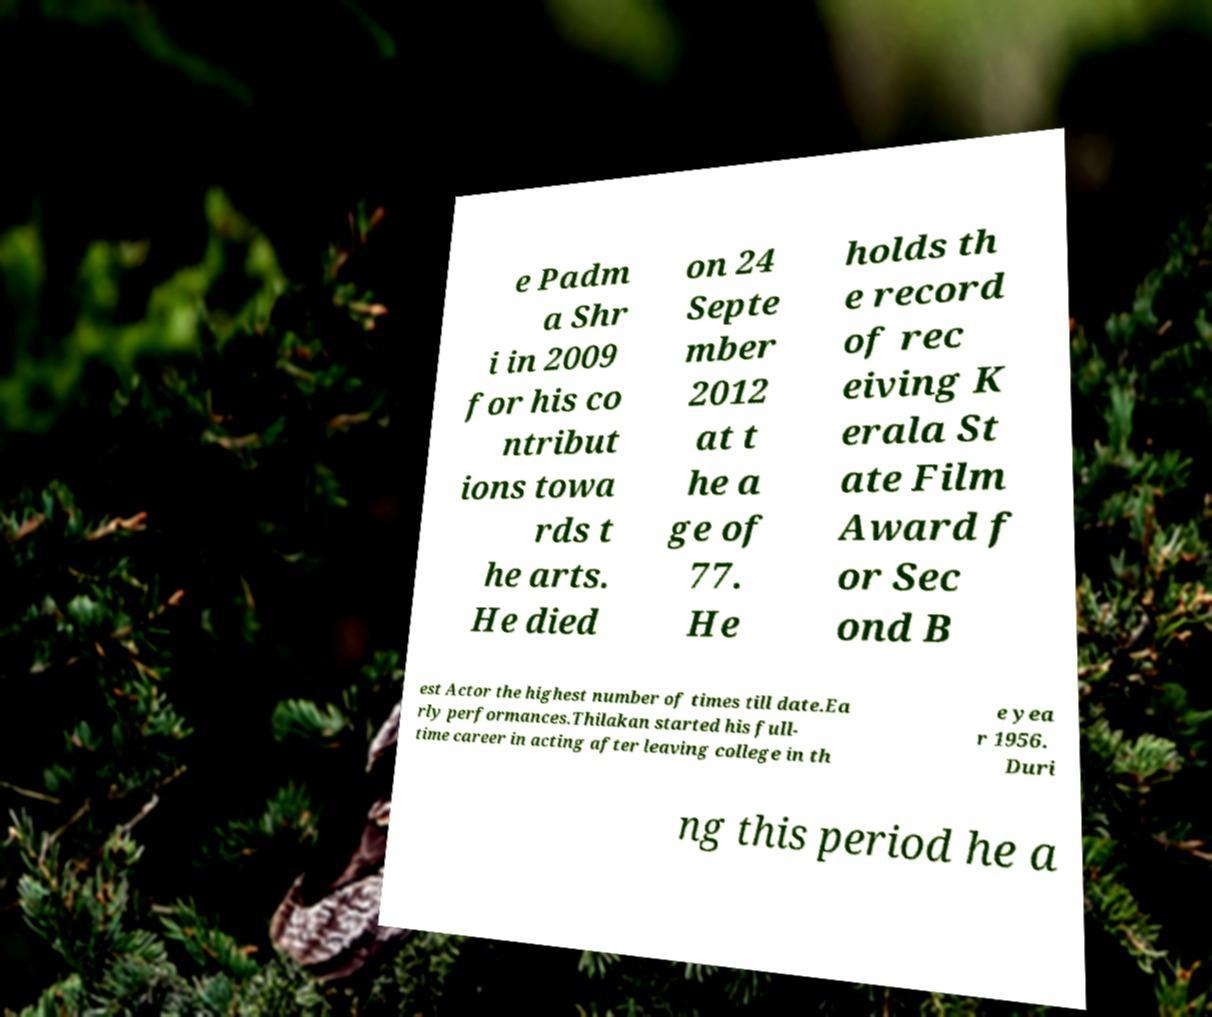I need the written content from this picture converted into text. Can you do that? e Padm a Shr i in 2009 for his co ntribut ions towa rds t he arts. He died on 24 Septe mber 2012 at t he a ge of 77. He holds th e record of rec eiving K erala St ate Film Award f or Sec ond B est Actor the highest number of times till date.Ea rly performances.Thilakan started his full- time career in acting after leaving college in th e yea r 1956. Duri ng this period he a 